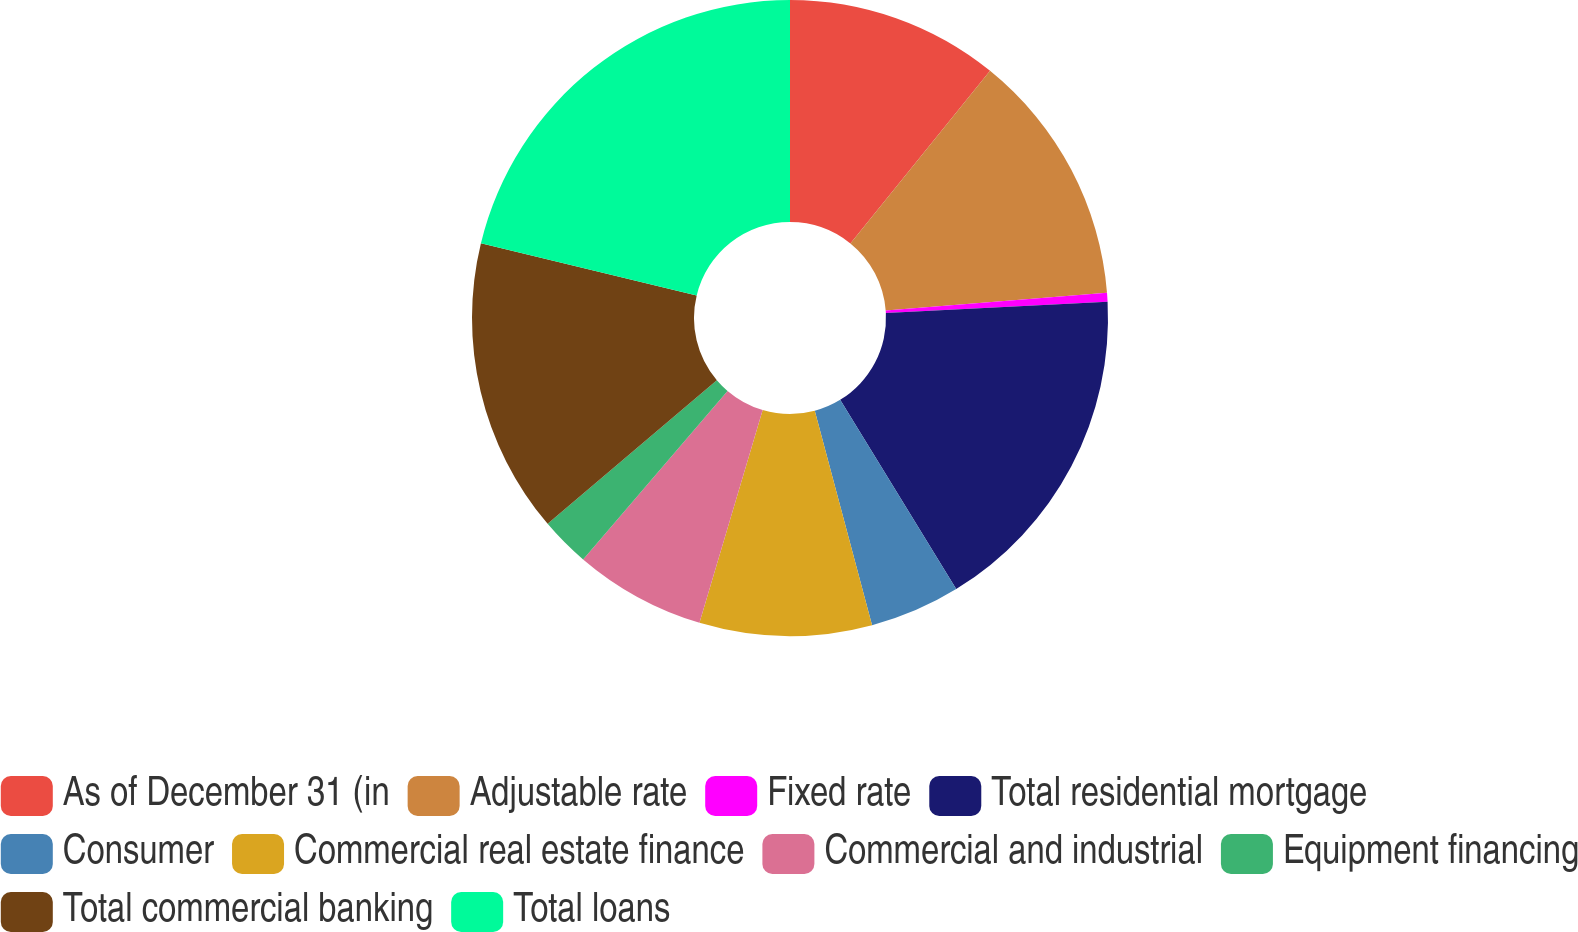Convert chart. <chart><loc_0><loc_0><loc_500><loc_500><pie_chart><fcel>As of December 31 (in<fcel>Adjustable rate<fcel>Fixed rate<fcel>Total residential mortgage<fcel>Consumer<fcel>Commercial real estate finance<fcel>Commercial and industrial<fcel>Equipment financing<fcel>Total commercial banking<fcel>Total loans<nl><fcel>10.83%<fcel>12.91%<fcel>0.45%<fcel>17.06%<fcel>4.6%<fcel>8.75%<fcel>6.68%<fcel>2.52%<fcel>14.99%<fcel>21.22%<nl></chart> 